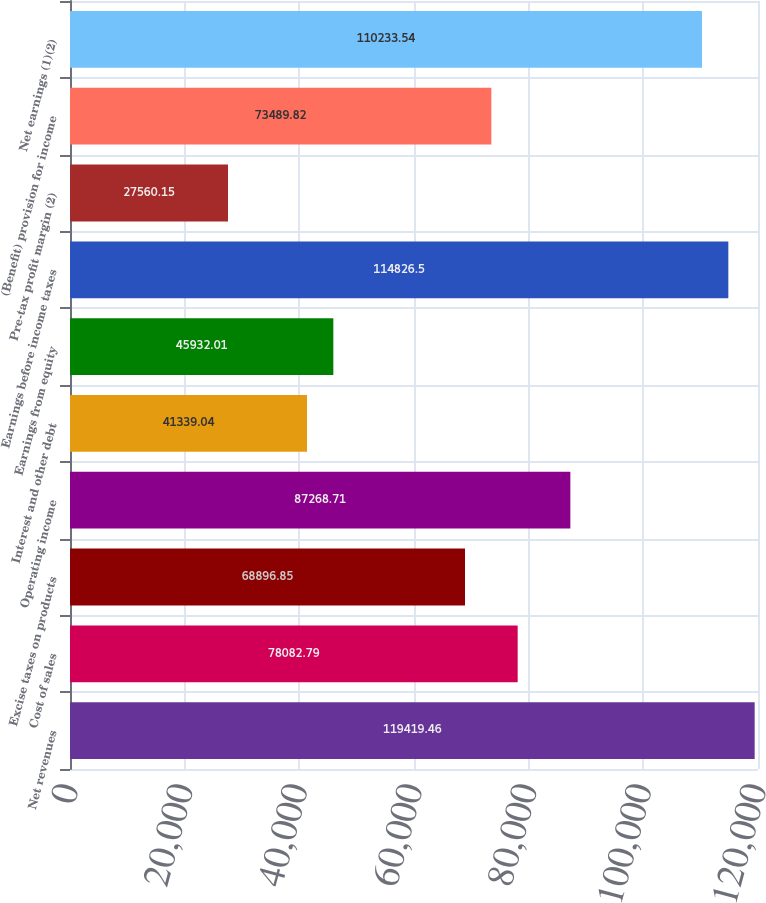<chart> <loc_0><loc_0><loc_500><loc_500><bar_chart><fcel>Net revenues<fcel>Cost of sales<fcel>Excise taxes on products<fcel>Operating income<fcel>Interest and other debt<fcel>Earnings from equity<fcel>Earnings before income taxes<fcel>Pre-tax profit margin (2)<fcel>(Benefit) provision for income<fcel>Net earnings (1)(2)<nl><fcel>119419<fcel>78082.8<fcel>68896.9<fcel>87268.7<fcel>41339<fcel>45932<fcel>114826<fcel>27560.2<fcel>73489.8<fcel>110234<nl></chart> 